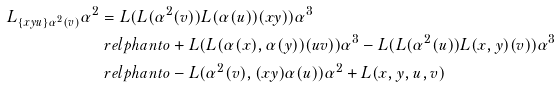<formula> <loc_0><loc_0><loc_500><loc_500>L _ { \{ x y u \} \alpha ^ { 2 } ( v ) } \alpha ^ { 2 } & = L ( L ( \alpha ^ { 2 } ( v ) ) L ( \alpha ( u ) ) ( x y ) ) \alpha ^ { 3 } \\ & \ r e l p h a n t o + L ( L ( \alpha ( x ) , \alpha ( y ) ) ( u v ) ) \alpha ^ { 3 } - L ( L ( \alpha ^ { 2 } ( u ) ) L ( x , y ) ( v ) ) \alpha ^ { 3 } \\ & \ r e l p h a n t o - L ( \alpha ^ { 2 } ( v ) , ( x y ) \alpha ( u ) ) \alpha ^ { 2 } + L ( x , y , u , v )</formula> 